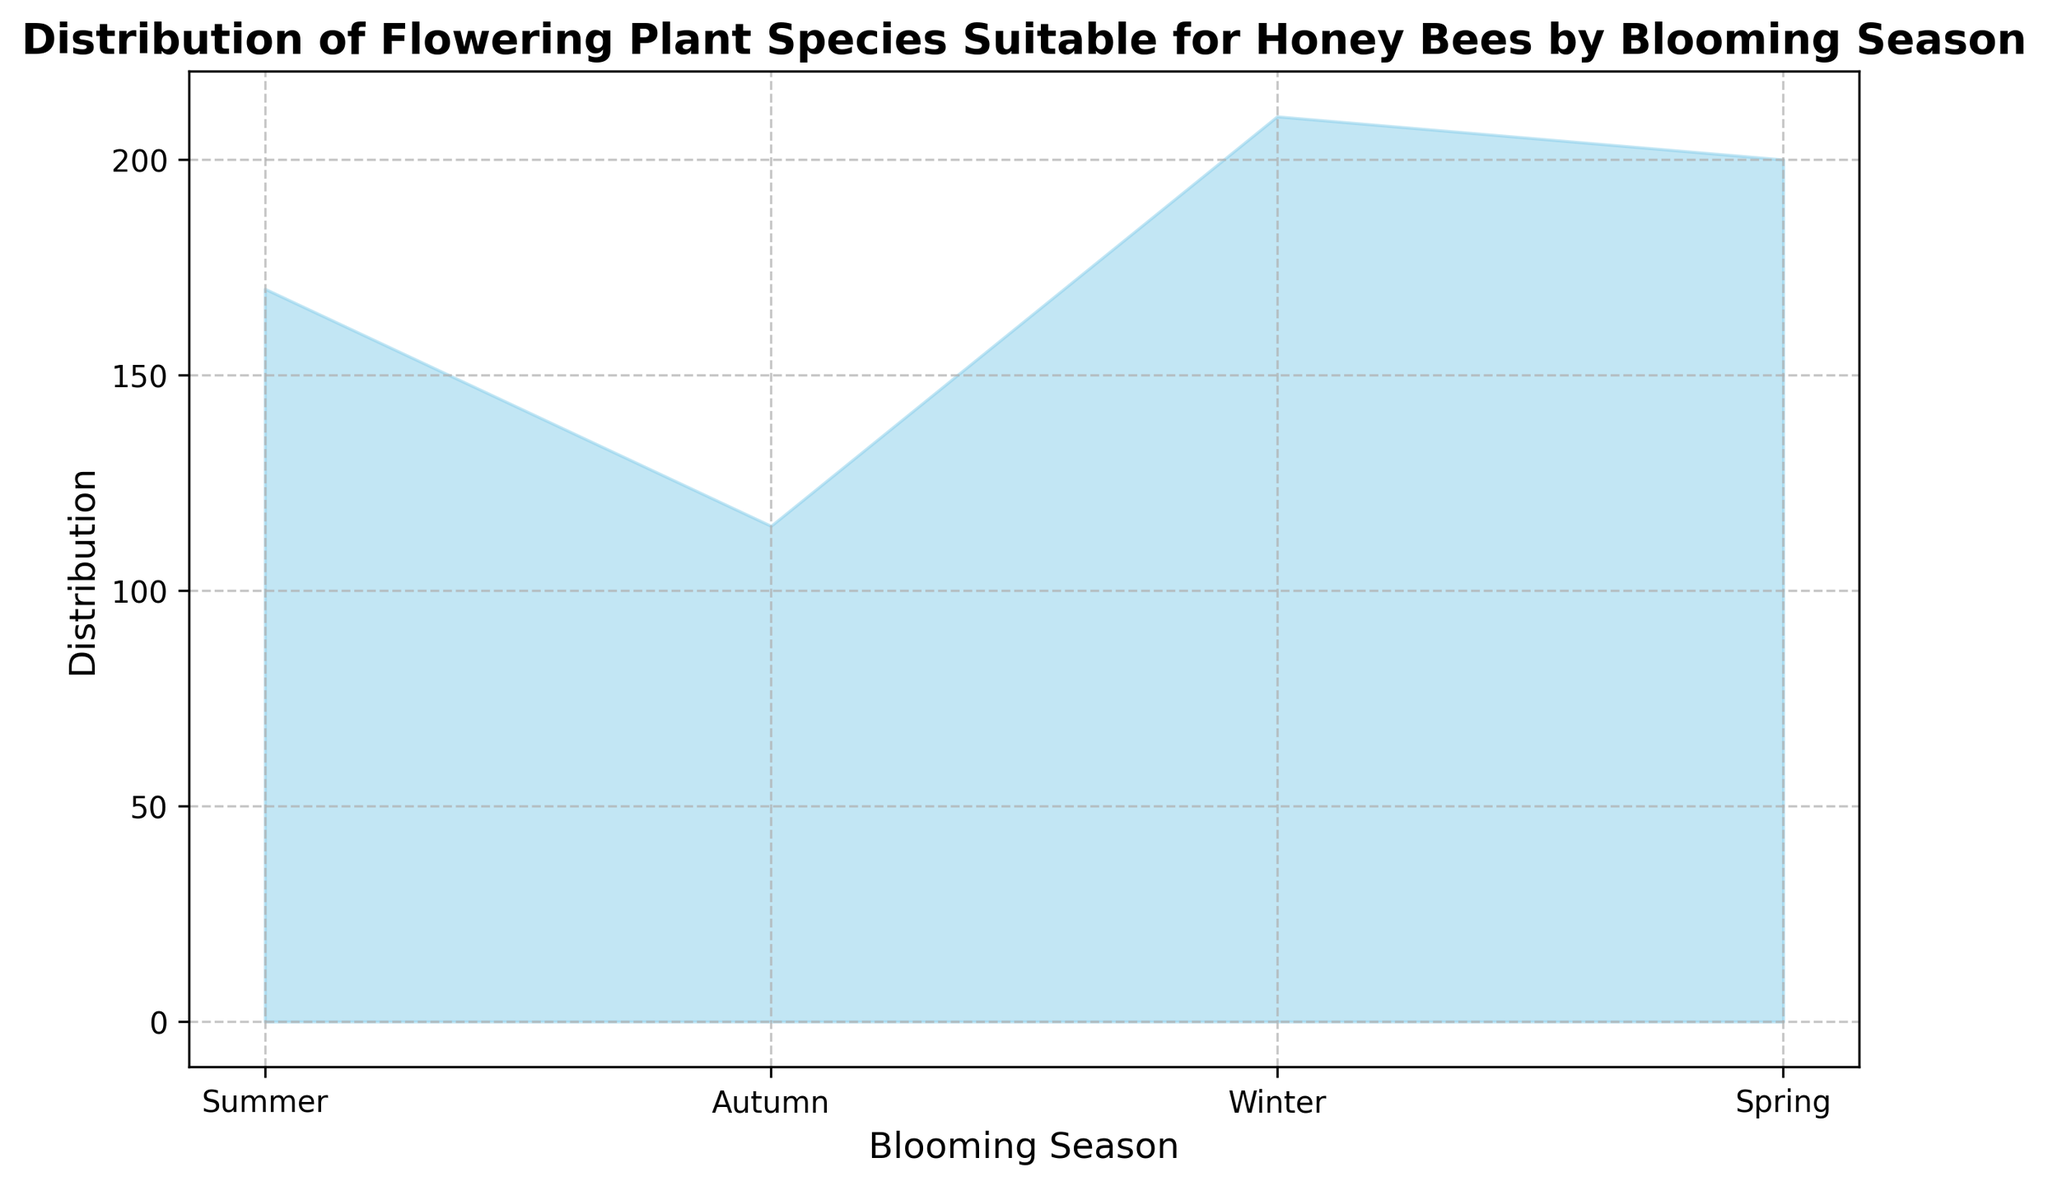Which blooming season has the highest distribution of flowering plant species suitable for honey bees? Look at the height of the filled area for each blooming season. The season with the highest peak is the one with the highest distribution. Winter has the highest peak.
Answer: Winter Which blooming season has the lowest distribution of flowering plant species suitable for honey bees? Compare the heights of the filled areas for all seasons. The season with the lowest peak is the one with the lowest distribution. Autumn has the lowest peak.
Answer: Autumn How does the distribution of flowering plant species in Summer compare to Spring? Compare the height of the filled area for Summer and Spring. Summer has a higher peak than Spring.
Answer: Summer is higher What's the total distribution of flowering plant species across all seasons? Sum the distribution values of all seasons. (Summer: 170, Autumn: 115, Winter: 210, Spring: 200) Total = 170 + 115 + 210 + 200 = 695
Answer: 695 Which two seasons combined have the highest distribution of flowering plant species suitable for honey bees? Calculate the sum of the distribution values for each combination of two seasons and identify the highest. (Summer+Autumn: 170+115=285, Summer+Winter: 170+210=380, Summer+Spring: 170+200=370, Autumn+Winter: 115+210=325, Autumn+Spring: 115+200=315, Winter+Spring: 210+200=410) Winter and Spring have the highest combined value of 410.
Answer: Winter and Spring During which season is the contribution from "Acacia pycnantha" highest? Identify the season associated with Acacia pycnantha. It blooms in Summer.
Answer: Summer How much higher is the distribution in Winter compared to Autumn? Subtract the distribution values of Autumn from Winter. Winter: 210, Autumn: 115. Difference = 210 - 115 = 95
Answer: 95 Is the combined distribution of Summer and Spring greater than Winter alone? Calculate the sums and compare. Summer: 170, Spring: 200, Winter: 210. Summer + Spring = 170 + 200 = 370, which is greater than Winter's 210.
Answer: Yes Of the four seasons, which one contributes the second-highest distribution of flowering plant species? Rank the distributions and find the second highest. Winter: 210, Spring: 200, Summer: 170, Autumn: 115. Spring is the second-highest.
Answer: Spring What proportion of the total distribution does Winter contribute? Divide Winter's distribution by the total distribution and convert to a percentage. Winter: 210, Total: 695. Proportion = (210/695) * 100 ≈ 30.22%
Answer: 30.22% 